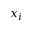Convert formula to latex. <formula><loc_0><loc_0><loc_500><loc_500>x _ { i }</formula> 